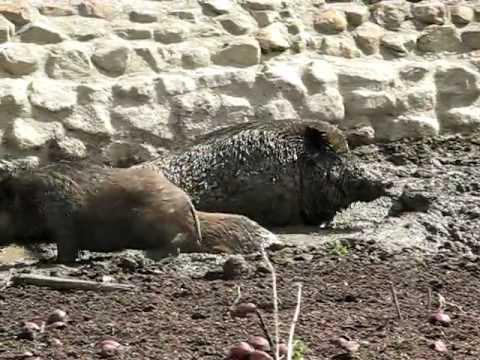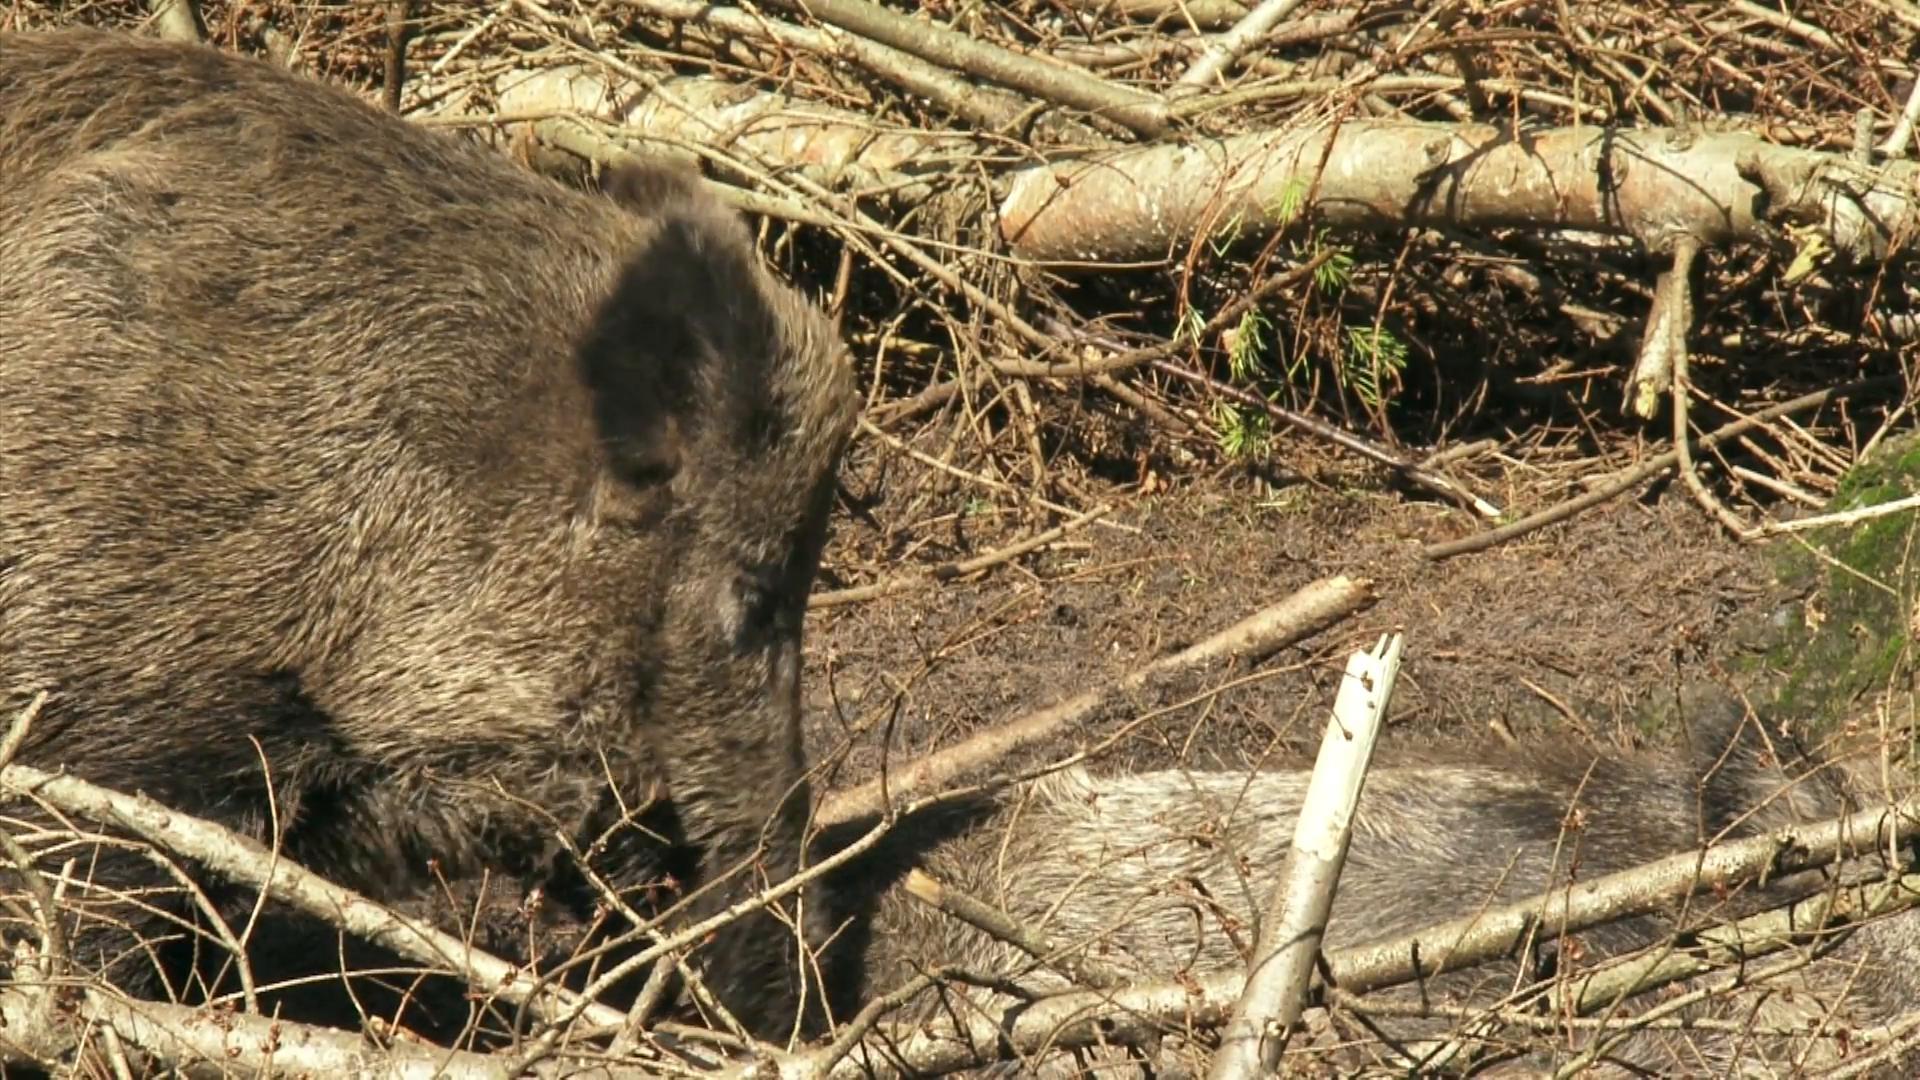The first image is the image on the left, the second image is the image on the right. For the images shown, is this caption "There are two wild boars in mud." true? Answer yes or no. No. The first image is the image on the left, the second image is the image on the right. For the images displayed, is the sentence "In at least one image there is a hog in the mud whose body is facing left while they rest." factually correct? Answer yes or no. No. 